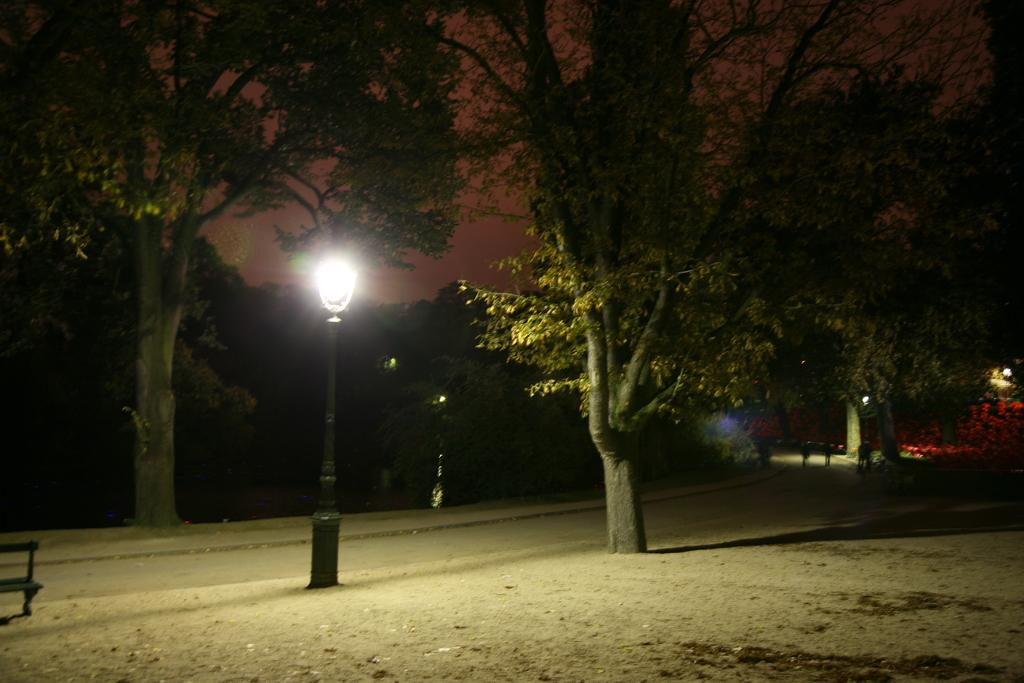What is the main feature of the image? There is a road in the image. What can be seen around the road? There are many trees around the road. Are there any people visible in the image? Yes, there are people on the right side of the image. What type of lighting is present in the image? There is a street light beside one of the trees. What type of ray is swimming in the image? There is no ray present in the image; it features a road with trees and people. Can you see a hose being used by the people in the image? There is no hose visible in the image. 